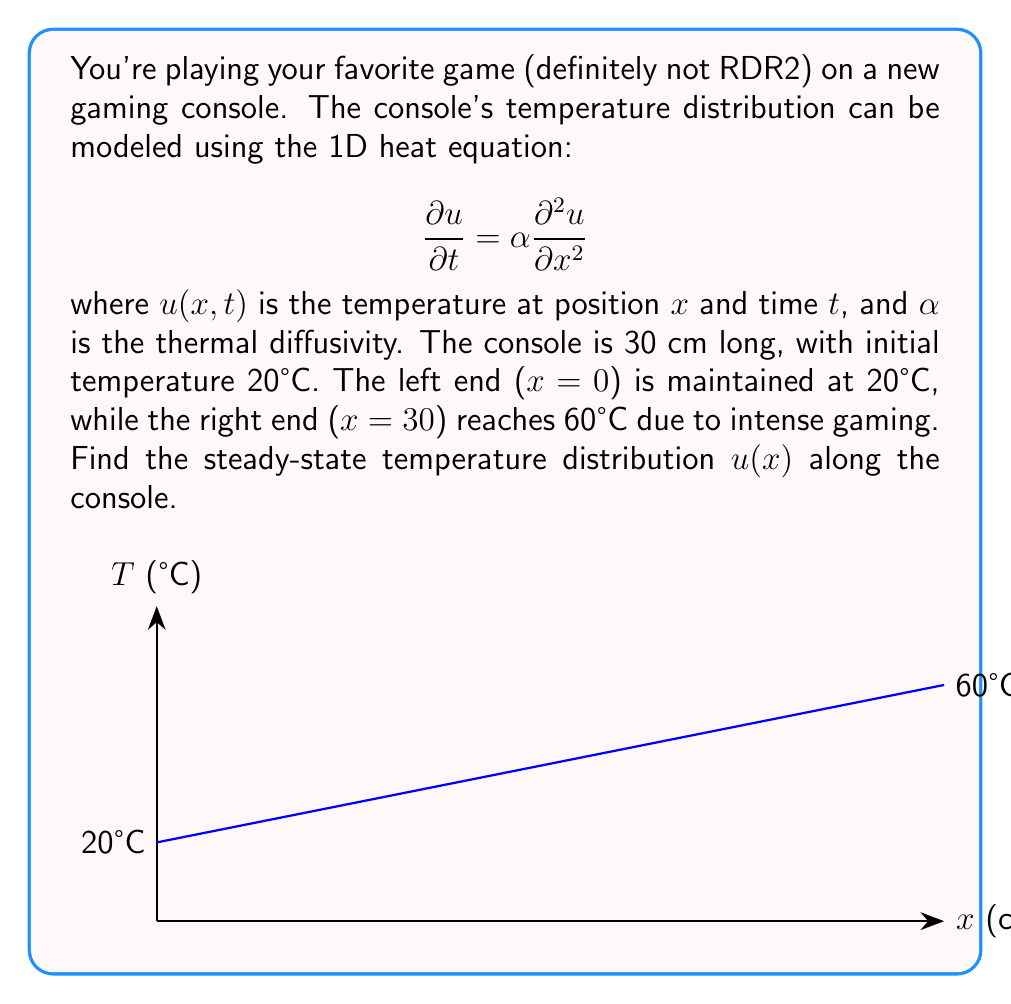Provide a solution to this math problem. Let's solve this step-by-step:

1) For steady-state, the temperature doesn't change with time, so $\frac{\partial u}{\partial t} = 0$. The heat equation becomes:

   $$0 = \alpha \frac{d^2 u}{dx^2}$$

2) This simplifies to:

   $$\frac{d^2 u}{dx^2} = 0$$

3) Integrating twice:

   $$\frac{du}{dx} = C_1$$
   $$u(x) = C_1x + C_2$$

4) We have boundary conditions:
   - At x = 0, u(0) = 20°C
   - At x = 30 cm, u(30) = 60°C

5) Applying these conditions:

   20 = C_2
   60 = 30C_1 + 20

6) Solving for C_1 and C_2:

   C_2 = 20
   C_1 = \frac{40}{30} = \frac{4}{3}

7) Therefore, the steady-state temperature distribution is:

   $$u(x) = \frac{4}{3}x + 20$$

Where x is in cm and u(x) is in °C.
Answer: $u(x) = \frac{4}{3}x + 20$, where x is in cm and u(x) is in °C. 